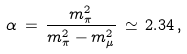<formula> <loc_0><loc_0><loc_500><loc_500>\alpha \, = \, \frac { m _ { \pi } ^ { 2 } } { m _ { \pi } ^ { 2 } - m _ { \mu } ^ { 2 } } \, \simeq \, 2 . 3 4 \, ,</formula> 